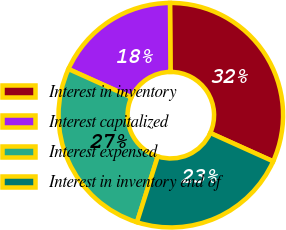Convert chart. <chart><loc_0><loc_0><loc_500><loc_500><pie_chart><fcel>Interest in inventory<fcel>Interest capitalized<fcel>Interest expensed<fcel>Interest in inventory end of<nl><fcel>31.86%<fcel>18.14%<fcel>26.87%<fcel>23.13%<nl></chart> 